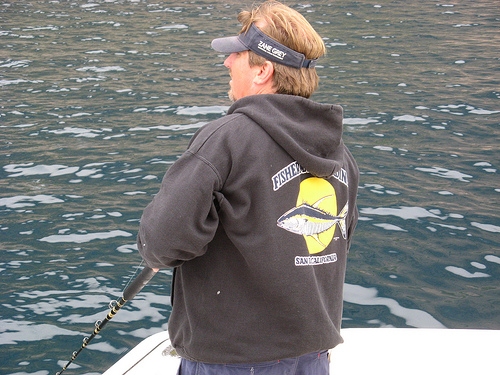<image>
Is the fish on the man? Yes. Looking at the image, I can see the fish is positioned on top of the man, with the man providing support. 